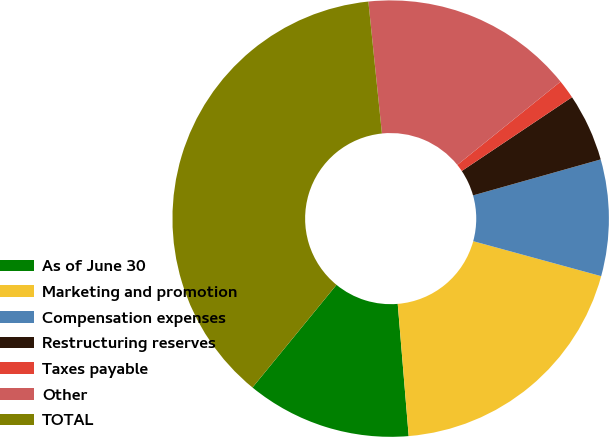Convert chart to OTSL. <chart><loc_0><loc_0><loc_500><loc_500><pie_chart><fcel>As of June 30<fcel>Marketing and promotion<fcel>Compensation expenses<fcel>Restructuring reserves<fcel>Taxes payable<fcel>Other<fcel>TOTAL<nl><fcel>12.23%<fcel>19.44%<fcel>8.62%<fcel>5.02%<fcel>1.41%<fcel>15.83%<fcel>37.46%<nl></chart> 